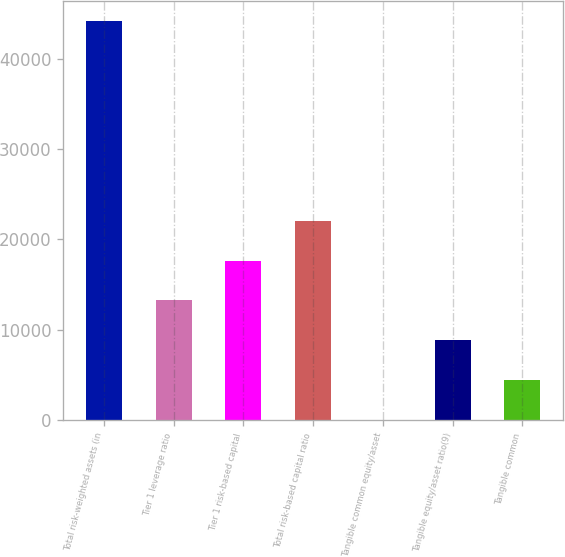<chart> <loc_0><loc_0><loc_500><loc_500><bar_chart><fcel>Total risk-weighted assets (in<fcel>Tier 1 leverage ratio<fcel>Tier 1 risk-based capital<fcel>Total risk-based capital ratio<fcel>Tangible common equity/asset<fcel>Tangible equity/asset ratio(9)<fcel>Tangible common<nl><fcel>44142<fcel>13247.1<fcel>17660.7<fcel>22074.2<fcel>6.46<fcel>8833.56<fcel>4420.01<nl></chart> 